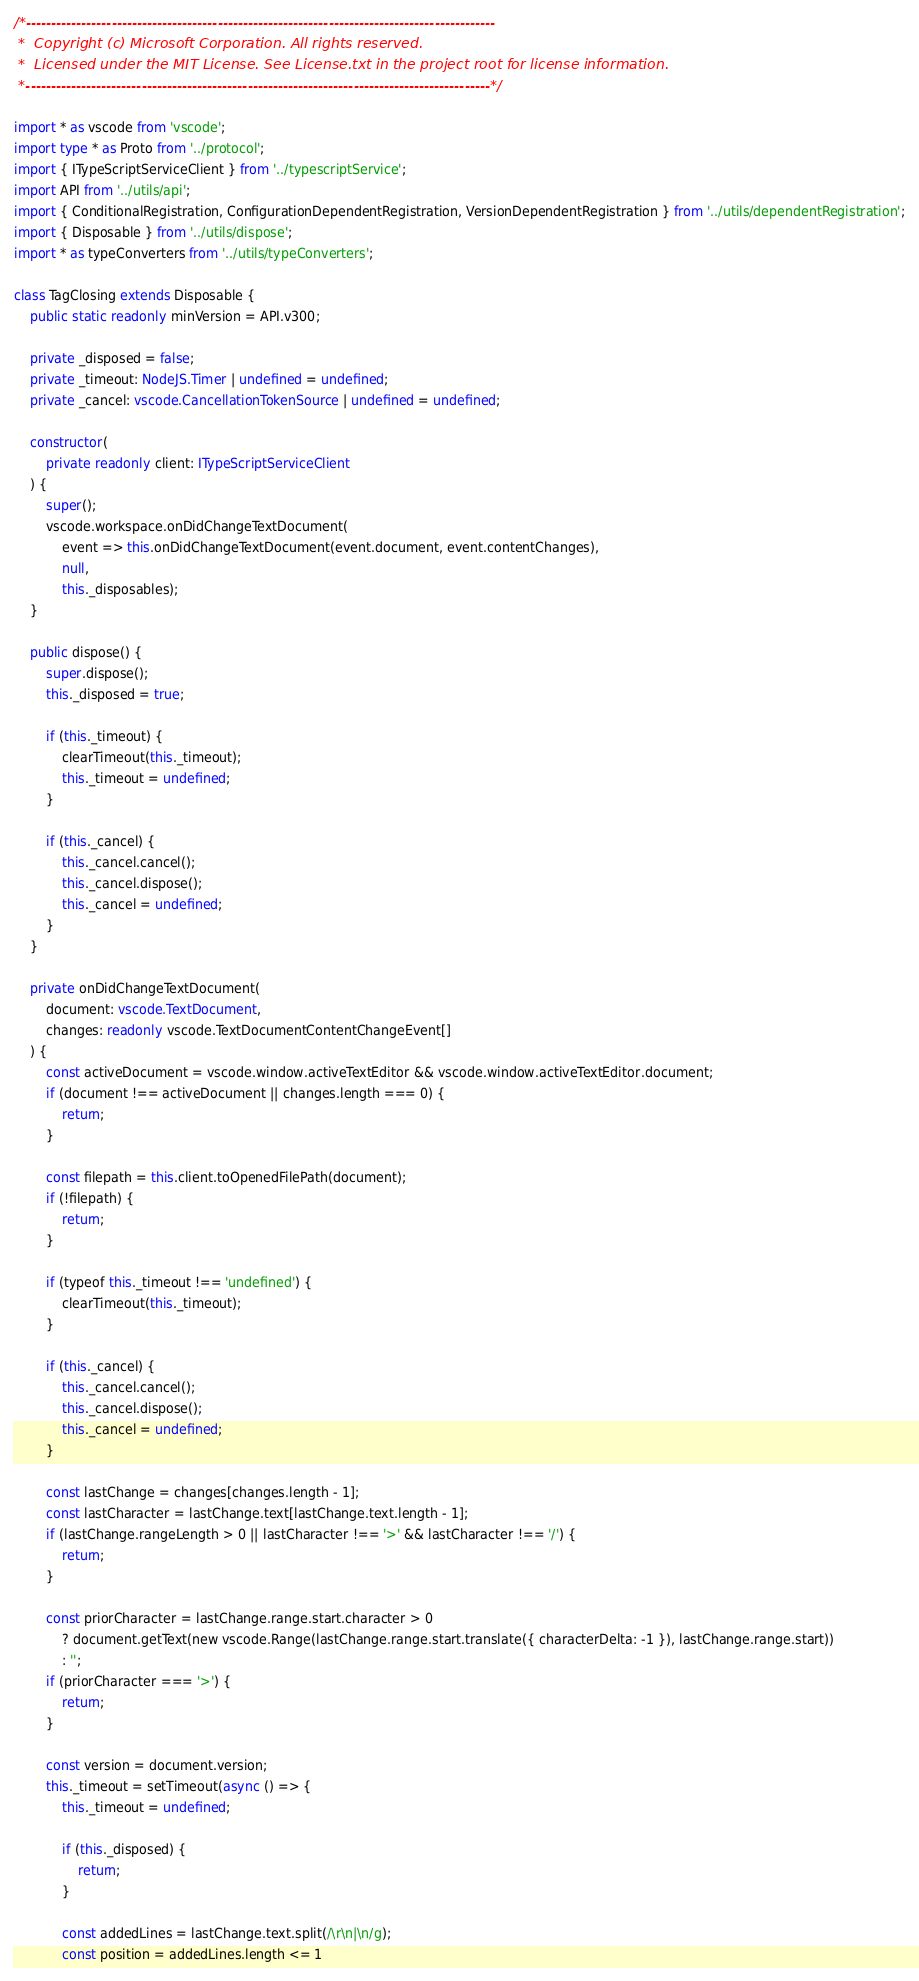Convert code to text. <code><loc_0><loc_0><loc_500><loc_500><_TypeScript_>/*---------------------------------------------------------------------------------------------
 *  Copyright (c) Microsoft Corporation. All rights reserved.
 *  Licensed under the MIT License. See License.txt in the project root for license information.
 *--------------------------------------------------------------------------------------------*/

import * as vscode from 'vscode';
import type * as Proto from '../protocol';
import { ITypeScriptServiceClient } from '../typescriptService';
import API from '../utils/api';
import { ConditionalRegistration, ConfigurationDependentRegistration, VersionDependentRegistration } from '../utils/dependentRegistration';
import { Disposable } from '../utils/dispose';
import * as typeConverters from '../utils/typeConverters';

class TagClosing extends Disposable {
	public static readonly minVersion = API.v300;

	private _disposed = false;
	private _timeout: NodeJS.Timer | undefined = undefined;
	private _cancel: vscode.CancellationTokenSource | undefined = undefined;

	constructor(
		private readonly client: ITypeScriptServiceClient
	) {
		super();
		vscode.workspace.onDidChangeTextDocument(
			event => this.onDidChangeTextDocument(event.document, event.contentChanges),
			null,
			this._disposables);
	}

	public dispose() {
		super.dispose();
		this._disposed = true;

		if (this._timeout) {
			clearTimeout(this._timeout);
			this._timeout = undefined;
		}

		if (this._cancel) {
			this._cancel.cancel();
			this._cancel.dispose();
			this._cancel = undefined;
		}
	}

	private onDidChangeTextDocument(
		document: vscode.TextDocument,
		changes: readonly vscode.TextDocumentContentChangeEvent[]
	) {
		const activeDocument = vscode.window.activeTextEditor && vscode.window.activeTextEditor.document;
		if (document !== activeDocument || changes.length === 0) {
			return;
		}

		const filepath = this.client.toOpenedFilePath(document);
		if (!filepath) {
			return;
		}

		if (typeof this._timeout !== 'undefined') {
			clearTimeout(this._timeout);
		}

		if (this._cancel) {
			this._cancel.cancel();
			this._cancel.dispose();
			this._cancel = undefined;
		}

		const lastChange = changes[changes.length - 1];
		const lastCharacter = lastChange.text[lastChange.text.length - 1];
		if (lastChange.rangeLength > 0 || lastCharacter !== '>' && lastCharacter !== '/') {
			return;
		}

		const priorCharacter = lastChange.range.start.character > 0
			? document.getText(new vscode.Range(lastChange.range.start.translate({ characterDelta: -1 }), lastChange.range.start))
			: '';
		if (priorCharacter === '>') {
			return;
		}

		const version = document.version;
		this._timeout = setTimeout(async () => {
			this._timeout = undefined;

			if (this._disposed) {
				return;
			}

			const addedLines = lastChange.text.split(/\r\n|\n/g);
			const position = addedLines.length <= 1</code> 